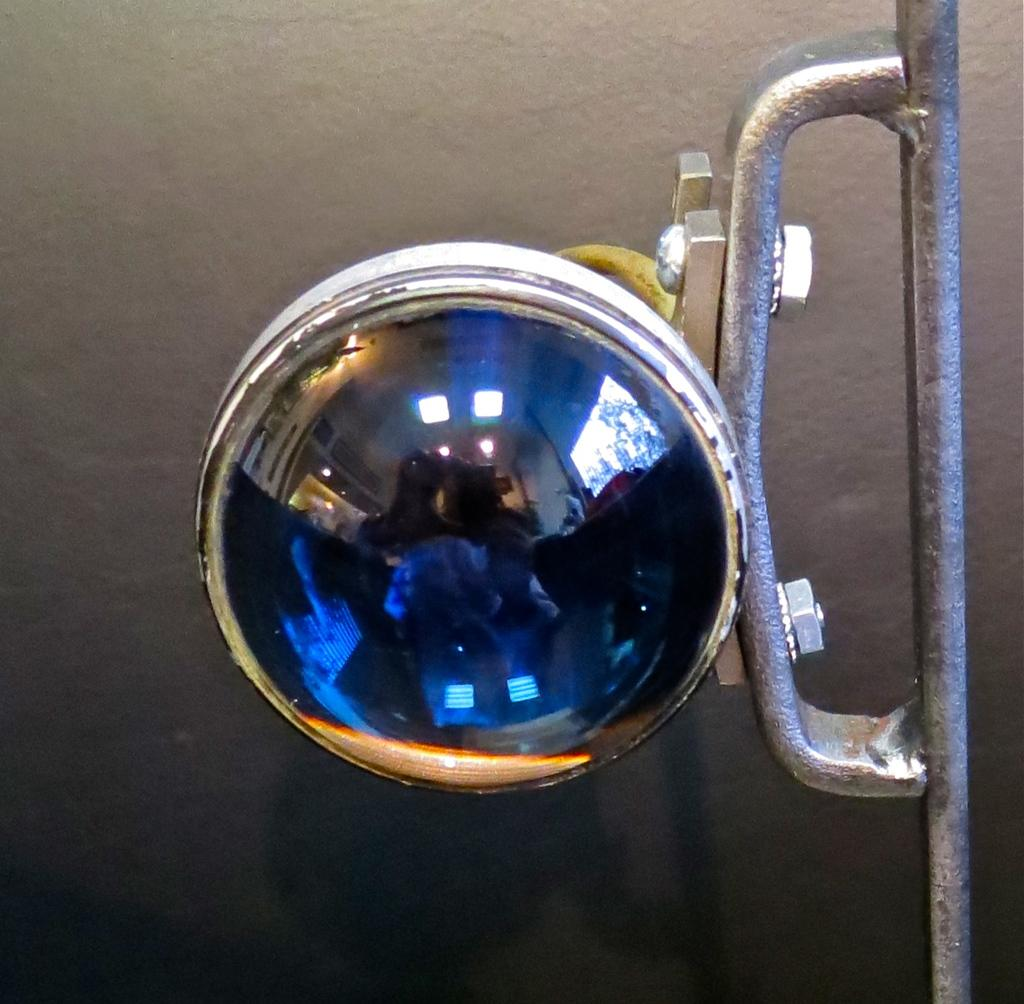What type of structure can be seen in the image? There is a wall in the image. What material is used for the iron metal in the image? The iron metal in the image is made of iron. What device is present in the image? There is a camera in the image. What connects the camera to the wall in the image? There is a wire in the image that connects the camera to the wall. What type of juice can be seen flowing through the wire in the image? There is no juice present in the image; it features a wall, iron metal, a camera, and a wire. How does the size of the camera affect its functionality in the image? The size of the camera is not mentioned in the image, so it cannot be determined how it affects its functionality. 